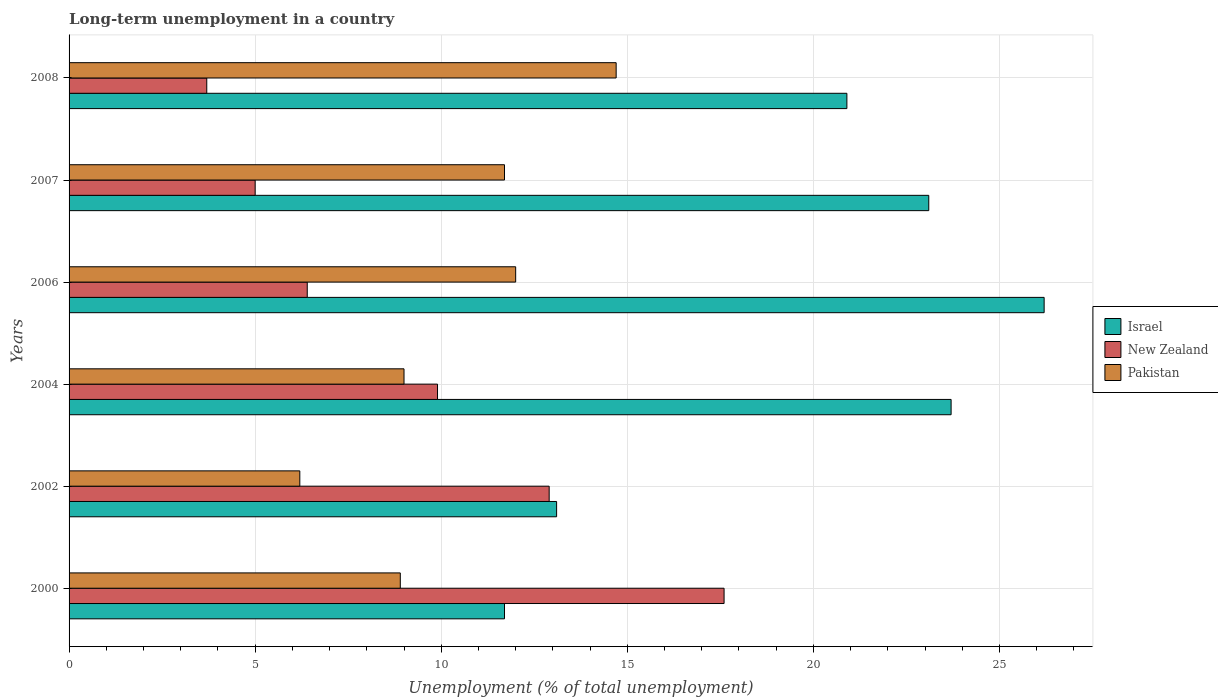Are the number of bars per tick equal to the number of legend labels?
Provide a short and direct response. Yes. How many bars are there on the 5th tick from the bottom?
Ensure brevity in your answer.  3. In how many cases, is the number of bars for a given year not equal to the number of legend labels?
Your answer should be compact. 0. What is the percentage of long-term unemployed population in New Zealand in 2004?
Make the answer very short. 9.9. Across all years, what is the maximum percentage of long-term unemployed population in New Zealand?
Offer a very short reply. 17.6. Across all years, what is the minimum percentage of long-term unemployed population in Pakistan?
Make the answer very short. 6.2. In which year was the percentage of long-term unemployed population in New Zealand minimum?
Your response must be concise. 2008. What is the total percentage of long-term unemployed population in Pakistan in the graph?
Ensure brevity in your answer.  62.5. What is the difference between the percentage of long-term unemployed population in New Zealand in 2002 and that in 2008?
Give a very brief answer. 9.2. What is the difference between the percentage of long-term unemployed population in Pakistan in 2004 and the percentage of long-term unemployed population in New Zealand in 2008?
Your answer should be compact. 5.3. What is the average percentage of long-term unemployed population in New Zealand per year?
Ensure brevity in your answer.  9.25. In the year 2006, what is the difference between the percentage of long-term unemployed population in New Zealand and percentage of long-term unemployed population in Pakistan?
Give a very brief answer. -5.6. What is the ratio of the percentage of long-term unemployed population in New Zealand in 2004 to that in 2006?
Offer a very short reply. 1.55. Is the percentage of long-term unemployed population in New Zealand in 2004 less than that in 2006?
Give a very brief answer. No. Is the difference between the percentage of long-term unemployed population in New Zealand in 2000 and 2004 greater than the difference between the percentage of long-term unemployed population in Pakistan in 2000 and 2004?
Provide a succinct answer. Yes. What is the difference between the highest and the second highest percentage of long-term unemployed population in Pakistan?
Ensure brevity in your answer.  2.7. What is the difference between the highest and the lowest percentage of long-term unemployed population in New Zealand?
Your answer should be very brief. 13.9. In how many years, is the percentage of long-term unemployed population in Israel greater than the average percentage of long-term unemployed population in Israel taken over all years?
Provide a short and direct response. 4. What does the 2nd bar from the bottom in 2008 represents?
Ensure brevity in your answer.  New Zealand. Is it the case that in every year, the sum of the percentage of long-term unemployed population in Israel and percentage of long-term unemployed population in New Zealand is greater than the percentage of long-term unemployed population in Pakistan?
Offer a terse response. Yes. How many bars are there?
Offer a very short reply. 18. What is the difference between two consecutive major ticks on the X-axis?
Your answer should be compact. 5. Are the values on the major ticks of X-axis written in scientific E-notation?
Provide a short and direct response. No. Does the graph contain any zero values?
Ensure brevity in your answer.  No. How many legend labels are there?
Offer a terse response. 3. What is the title of the graph?
Ensure brevity in your answer.  Long-term unemployment in a country. Does "Least developed countries" appear as one of the legend labels in the graph?
Keep it short and to the point. No. What is the label or title of the X-axis?
Offer a very short reply. Unemployment (% of total unemployment). What is the label or title of the Y-axis?
Make the answer very short. Years. What is the Unemployment (% of total unemployment) in Israel in 2000?
Keep it short and to the point. 11.7. What is the Unemployment (% of total unemployment) in New Zealand in 2000?
Give a very brief answer. 17.6. What is the Unemployment (% of total unemployment) in Pakistan in 2000?
Offer a very short reply. 8.9. What is the Unemployment (% of total unemployment) of Israel in 2002?
Provide a short and direct response. 13.1. What is the Unemployment (% of total unemployment) of New Zealand in 2002?
Keep it short and to the point. 12.9. What is the Unemployment (% of total unemployment) in Pakistan in 2002?
Your answer should be very brief. 6.2. What is the Unemployment (% of total unemployment) of Israel in 2004?
Your answer should be very brief. 23.7. What is the Unemployment (% of total unemployment) of New Zealand in 2004?
Provide a succinct answer. 9.9. What is the Unemployment (% of total unemployment) of Israel in 2006?
Ensure brevity in your answer.  26.2. What is the Unemployment (% of total unemployment) in New Zealand in 2006?
Make the answer very short. 6.4. What is the Unemployment (% of total unemployment) of Pakistan in 2006?
Provide a short and direct response. 12. What is the Unemployment (% of total unemployment) of Israel in 2007?
Keep it short and to the point. 23.1. What is the Unemployment (% of total unemployment) of Pakistan in 2007?
Your answer should be very brief. 11.7. What is the Unemployment (% of total unemployment) in Israel in 2008?
Make the answer very short. 20.9. What is the Unemployment (% of total unemployment) in New Zealand in 2008?
Offer a very short reply. 3.7. What is the Unemployment (% of total unemployment) of Pakistan in 2008?
Keep it short and to the point. 14.7. Across all years, what is the maximum Unemployment (% of total unemployment) of Israel?
Keep it short and to the point. 26.2. Across all years, what is the maximum Unemployment (% of total unemployment) of New Zealand?
Your response must be concise. 17.6. Across all years, what is the maximum Unemployment (% of total unemployment) in Pakistan?
Your answer should be very brief. 14.7. Across all years, what is the minimum Unemployment (% of total unemployment) of Israel?
Keep it short and to the point. 11.7. Across all years, what is the minimum Unemployment (% of total unemployment) of New Zealand?
Keep it short and to the point. 3.7. Across all years, what is the minimum Unemployment (% of total unemployment) of Pakistan?
Keep it short and to the point. 6.2. What is the total Unemployment (% of total unemployment) in Israel in the graph?
Offer a terse response. 118.7. What is the total Unemployment (% of total unemployment) of New Zealand in the graph?
Provide a succinct answer. 55.5. What is the total Unemployment (% of total unemployment) of Pakistan in the graph?
Make the answer very short. 62.5. What is the difference between the Unemployment (% of total unemployment) of Israel in 2000 and that in 2002?
Ensure brevity in your answer.  -1.4. What is the difference between the Unemployment (% of total unemployment) in New Zealand in 2000 and that in 2002?
Offer a terse response. 4.7. What is the difference between the Unemployment (% of total unemployment) of Pakistan in 2000 and that in 2002?
Provide a succinct answer. 2.7. What is the difference between the Unemployment (% of total unemployment) in New Zealand in 2000 and that in 2004?
Make the answer very short. 7.7. What is the difference between the Unemployment (% of total unemployment) in Israel in 2000 and that in 2007?
Make the answer very short. -11.4. What is the difference between the Unemployment (% of total unemployment) of Israel in 2000 and that in 2008?
Offer a very short reply. -9.2. What is the difference between the Unemployment (% of total unemployment) of Israel in 2002 and that in 2004?
Your answer should be compact. -10.6. What is the difference between the Unemployment (% of total unemployment) of New Zealand in 2002 and that in 2004?
Offer a very short reply. 3. What is the difference between the Unemployment (% of total unemployment) in Pakistan in 2002 and that in 2004?
Your response must be concise. -2.8. What is the difference between the Unemployment (% of total unemployment) in Israel in 2002 and that in 2006?
Offer a very short reply. -13.1. What is the difference between the Unemployment (% of total unemployment) in Pakistan in 2002 and that in 2006?
Offer a terse response. -5.8. What is the difference between the Unemployment (% of total unemployment) of Pakistan in 2002 and that in 2007?
Give a very brief answer. -5.5. What is the difference between the Unemployment (% of total unemployment) of New Zealand in 2004 and that in 2006?
Your answer should be very brief. 3.5. What is the difference between the Unemployment (% of total unemployment) of Pakistan in 2004 and that in 2008?
Your answer should be compact. -5.7. What is the difference between the Unemployment (% of total unemployment) of Israel in 2006 and that in 2007?
Provide a short and direct response. 3.1. What is the difference between the Unemployment (% of total unemployment) of Israel in 2006 and that in 2008?
Ensure brevity in your answer.  5.3. What is the difference between the Unemployment (% of total unemployment) in New Zealand in 2006 and that in 2008?
Keep it short and to the point. 2.7. What is the difference between the Unemployment (% of total unemployment) in Pakistan in 2006 and that in 2008?
Your answer should be very brief. -2.7. What is the difference between the Unemployment (% of total unemployment) of Pakistan in 2007 and that in 2008?
Your response must be concise. -3. What is the difference between the Unemployment (% of total unemployment) of Israel in 2000 and the Unemployment (% of total unemployment) of New Zealand in 2002?
Provide a short and direct response. -1.2. What is the difference between the Unemployment (% of total unemployment) of Israel in 2000 and the Unemployment (% of total unemployment) of New Zealand in 2004?
Offer a very short reply. 1.8. What is the difference between the Unemployment (% of total unemployment) in Israel in 2000 and the Unemployment (% of total unemployment) in Pakistan in 2004?
Your answer should be compact. 2.7. What is the difference between the Unemployment (% of total unemployment) of New Zealand in 2000 and the Unemployment (% of total unemployment) of Pakistan in 2004?
Offer a terse response. 8.6. What is the difference between the Unemployment (% of total unemployment) in Israel in 2000 and the Unemployment (% of total unemployment) in Pakistan in 2006?
Make the answer very short. -0.3. What is the difference between the Unemployment (% of total unemployment) in New Zealand in 2000 and the Unemployment (% of total unemployment) in Pakistan in 2006?
Your answer should be compact. 5.6. What is the difference between the Unemployment (% of total unemployment) in Israel in 2000 and the Unemployment (% of total unemployment) in Pakistan in 2007?
Make the answer very short. 0. What is the difference between the Unemployment (% of total unemployment) in New Zealand in 2000 and the Unemployment (% of total unemployment) in Pakistan in 2008?
Offer a very short reply. 2.9. What is the difference between the Unemployment (% of total unemployment) of Israel in 2002 and the Unemployment (% of total unemployment) of New Zealand in 2004?
Offer a very short reply. 3.2. What is the difference between the Unemployment (% of total unemployment) of Israel in 2002 and the Unemployment (% of total unemployment) of Pakistan in 2004?
Give a very brief answer. 4.1. What is the difference between the Unemployment (% of total unemployment) in New Zealand in 2002 and the Unemployment (% of total unemployment) in Pakistan in 2004?
Offer a very short reply. 3.9. What is the difference between the Unemployment (% of total unemployment) in Israel in 2002 and the Unemployment (% of total unemployment) in New Zealand in 2006?
Offer a very short reply. 6.7. What is the difference between the Unemployment (% of total unemployment) of Israel in 2002 and the Unemployment (% of total unemployment) of Pakistan in 2006?
Make the answer very short. 1.1. What is the difference between the Unemployment (% of total unemployment) in Israel in 2002 and the Unemployment (% of total unemployment) in New Zealand in 2007?
Keep it short and to the point. 8.1. What is the difference between the Unemployment (% of total unemployment) of New Zealand in 2002 and the Unemployment (% of total unemployment) of Pakistan in 2007?
Give a very brief answer. 1.2. What is the difference between the Unemployment (% of total unemployment) in Israel in 2002 and the Unemployment (% of total unemployment) in New Zealand in 2008?
Give a very brief answer. 9.4. What is the difference between the Unemployment (% of total unemployment) of Israel in 2004 and the Unemployment (% of total unemployment) of New Zealand in 2006?
Ensure brevity in your answer.  17.3. What is the difference between the Unemployment (% of total unemployment) of Israel in 2004 and the Unemployment (% of total unemployment) of Pakistan in 2006?
Make the answer very short. 11.7. What is the difference between the Unemployment (% of total unemployment) of New Zealand in 2004 and the Unemployment (% of total unemployment) of Pakistan in 2007?
Provide a succinct answer. -1.8. What is the difference between the Unemployment (% of total unemployment) of New Zealand in 2004 and the Unemployment (% of total unemployment) of Pakistan in 2008?
Your answer should be very brief. -4.8. What is the difference between the Unemployment (% of total unemployment) in Israel in 2006 and the Unemployment (% of total unemployment) in New Zealand in 2007?
Your response must be concise. 21.2. What is the difference between the Unemployment (% of total unemployment) of Israel in 2006 and the Unemployment (% of total unemployment) of Pakistan in 2008?
Offer a terse response. 11.5. What is the difference between the Unemployment (% of total unemployment) of Israel in 2007 and the Unemployment (% of total unemployment) of New Zealand in 2008?
Provide a short and direct response. 19.4. What is the difference between the Unemployment (% of total unemployment) of New Zealand in 2007 and the Unemployment (% of total unemployment) of Pakistan in 2008?
Make the answer very short. -9.7. What is the average Unemployment (% of total unemployment) of Israel per year?
Keep it short and to the point. 19.78. What is the average Unemployment (% of total unemployment) of New Zealand per year?
Ensure brevity in your answer.  9.25. What is the average Unemployment (% of total unemployment) in Pakistan per year?
Give a very brief answer. 10.42. In the year 2000, what is the difference between the Unemployment (% of total unemployment) of Israel and Unemployment (% of total unemployment) of Pakistan?
Give a very brief answer. 2.8. In the year 2004, what is the difference between the Unemployment (% of total unemployment) in Israel and Unemployment (% of total unemployment) in New Zealand?
Your answer should be compact. 13.8. In the year 2004, what is the difference between the Unemployment (% of total unemployment) of Israel and Unemployment (% of total unemployment) of Pakistan?
Keep it short and to the point. 14.7. In the year 2004, what is the difference between the Unemployment (% of total unemployment) of New Zealand and Unemployment (% of total unemployment) of Pakistan?
Your answer should be compact. 0.9. In the year 2006, what is the difference between the Unemployment (% of total unemployment) in Israel and Unemployment (% of total unemployment) in New Zealand?
Your answer should be compact. 19.8. In the year 2006, what is the difference between the Unemployment (% of total unemployment) of Israel and Unemployment (% of total unemployment) of Pakistan?
Provide a succinct answer. 14.2. In the year 2006, what is the difference between the Unemployment (% of total unemployment) in New Zealand and Unemployment (% of total unemployment) in Pakistan?
Your response must be concise. -5.6. In the year 2007, what is the difference between the Unemployment (% of total unemployment) of Israel and Unemployment (% of total unemployment) of New Zealand?
Make the answer very short. 18.1. In the year 2007, what is the difference between the Unemployment (% of total unemployment) of New Zealand and Unemployment (% of total unemployment) of Pakistan?
Make the answer very short. -6.7. In the year 2008, what is the difference between the Unemployment (% of total unemployment) in Israel and Unemployment (% of total unemployment) in Pakistan?
Keep it short and to the point. 6.2. What is the ratio of the Unemployment (% of total unemployment) in Israel in 2000 to that in 2002?
Make the answer very short. 0.89. What is the ratio of the Unemployment (% of total unemployment) of New Zealand in 2000 to that in 2002?
Offer a very short reply. 1.36. What is the ratio of the Unemployment (% of total unemployment) in Pakistan in 2000 to that in 2002?
Offer a terse response. 1.44. What is the ratio of the Unemployment (% of total unemployment) in Israel in 2000 to that in 2004?
Make the answer very short. 0.49. What is the ratio of the Unemployment (% of total unemployment) in New Zealand in 2000 to that in 2004?
Your answer should be compact. 1.78. What is the ratio of the Unemployment (% of total unemployment) in Pakistan in 2000 to that in 2004?
Provide a short and direct response. 0.99. What is the ratio of the Unemployment (% of total unemployment) of Israel in 2000 to that in 2006?
Your response must be concise. 0.45. What is the ratio of the Unemployment (% of total unemployment) in New Zealand in 2000 to that in 2006?
Your answer should be very brief. 2.75. What is the ratio of the Unemployment (% of total unemployment) of Pakistan in 2000 to that in 2006?
Offer a terse response. 0.74. What is the ratio of the Unemployment (% of total unemployment) of Israel in 2000 to that in 2007?
Offer a very short reply. 0.51. What is the ratio of the Unemployment (% of total unemployment) of New Zealand in 2000 to that in 2007?
Make the answer very short. 3.52. What is the ratio of the Unemployment (% of total unemployment) of Pakistan in 2000 to that in 2007?
Make the answer very short. 0.76. What is the ratio of the Unemployment (% of total unemployment) in Israel in 2000 to that in 2008?
Ensure brevity in your answer.  0.56. What is the ratio of the Unemployment (% of total unemployment) of New Zealand in 2000 to that in 2008?
Offer a terse response. 4.76. What is the ratio of the Unemployment (% of total unemployment) of Pakistan in 2000 to that in 2008?
Provide a short and direct response. 0.61. What is the ratio of the Unemployment (% of total unemployment) of Israel in 2002 to that in 2004?
Make the answer very short. 0.55. What is the ratio of the Unemployment (% of total unemployment) in New Zealand in 2002 to that in 2004?
Your answer should be very brief. 1.3. What is the ratio of the Unemployment (% of total unemployment) in Pakistan in 2002 to that in 2004?
Keep it short and to the point. 0.69. What is the ratio of the Unemployment (% of total unemployment) of New Zealand in 2002 to that in 2006?
Make the answer very short. 2.02. What is the ratio of the Unemployment (% of total unemployment) of Pakistan in 2002 to that in 2006?
Offer a terse response. 0.52. What is the ratio of the Unemployment (% of total unemployment) of Israel in 2002 to that in 2007?
Keep it short and to the point. 0.57. What is the ratio of the Unemployment (% of total unemployment) of New Zealand in 2002 to that in 2007?
Your response must be concise. 2.58. What is the ratio of the Unemployment (% of total unemployment) in Pakistan in 2002 to that in 2007?
Keep it short and to the point. 0.53. What is the ratio of the Unemployment (% of total unemployment) in Israel in 2002 to that in 2008?
Offer a terse response. 0.63. What is the ratio of the Unemployment (% of total unemployment) in New Zealand in 2002 to that in 2008?
Ensure brevity in your answer.  3.49. What is the ratio of the Unemployment (% of total unemployment) in Pakistan in 2002 to that in 2008?
Your answer should be very brief. 0.42. What is the ratio of the Unemployment (% of total unemployment) in Israel in 2004 to that in 2006?
Offer a terse response. 0.9. What is the ratio of the Unemployment (% of total unemployment) in New Zealand in 2004 to that in 2006?
Give a very brief answer. 1.55. What is the ratio of the Unemployment (% of total unemployment) of New Zealand in 2004 to that in 2007?
Give a very brief answer. 1.98. What is the ratio of the Unemployment (% of total unemployment) in Pakistan in 2004 to that in 2007?
Provide a succinct answer. 0.77. What is the ratio of the Unemployment (% of total unemployment) of Israel in 2004 to that in 2008?
Give a very brief answer. 1.13. What is the ratio of the Unemployment (% of total unemployment) of New Zealand in 2004 to that in 2008?
Make the answer very short. 2.68. What is the ratio of the Unemployment (% of total unemployment) of Pakistan in 2004 to that in 2008?
Your response must be concise. 0.61. What is the ratio of the Unemployment (% of total unemployment) of Israel in 2006 to that in 2007?
Keep it short and to the point. 1.13. What is the ratio of the Unemployment (% of total unemployment) of New Zealand in 2006 to that in 2007?
Ensure brevity in your answer.  1.28. What is the ratio of the Unemployment (% of total unemployment) in Pakistan in 2006 to that in 2007?
Ensure brevity in your answer.  1.03. What is the ratio of the Unemployment (% of total unemployment) of Israel in 2006 to that in 2008?
Give a very brief answer. 1.25. What is the ratio of the Unemployment (% of total unemployment) of New Zealand in 2006 to that in 2008?
Your response must be concise. 1.73. What is the ratio of the Unemployment (% of total unemployment) in Pakistan in 2006 to that in 2008?
Offer a very short reply. 0.82. What is the ratio of the Unemployment (% of total unemployment) of Israel in 2007 to that in 2008?
Your response must be concise. 1.11. What is the ratio of the Unemployment (% of total unemployment) in New Zealand in 2007 to that in 2008?
Ensure brevity in your answer.  1.35. What is the ratio of the Unemployment (% of total unemployment) in Pakistan in 2007 to that in 2008?
Offer a very short reply. 0.8. What is the difference between the highest and the second highest Unemployment (% of total unemployment) in New Zealand?
Make the answer very short. 4.7. What is the difference between the highest and the second highest Unemployment (% of total unemployment) of Pakistan?
Ensure brevity in your answer.  2.7. What is the difference between the highest and the lowest Unemployment (% of total unemployment) in Israel?
Provide a succinct answer. 14.5. 